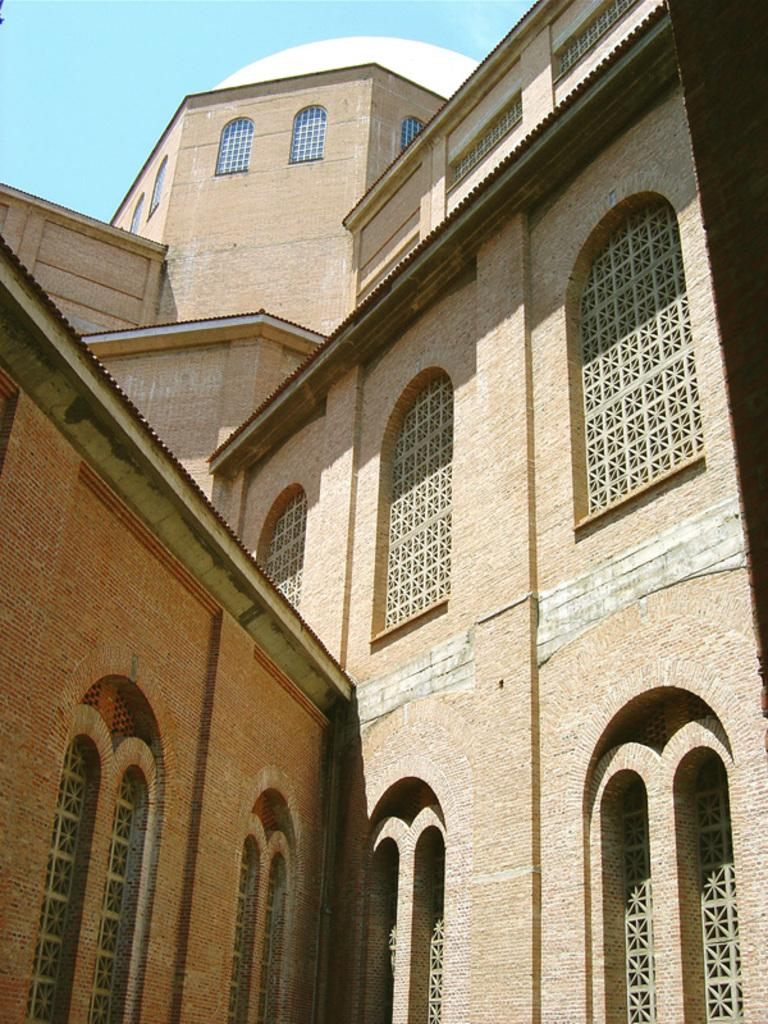What type of structure is present in the image? There is a building in the image. What architectural features can be seen on the building? The building has arches and windows. What is visible at the top of the image? The sky is visible at the top of the image. Can you see any sparks coming from the building in the image? There are no sparks visible in the image; it only shows a building with arches and windows. Is there a cat sitting on the roof of the building in the image? There is no cat present in the image; it only shows a building with arches and windows. 